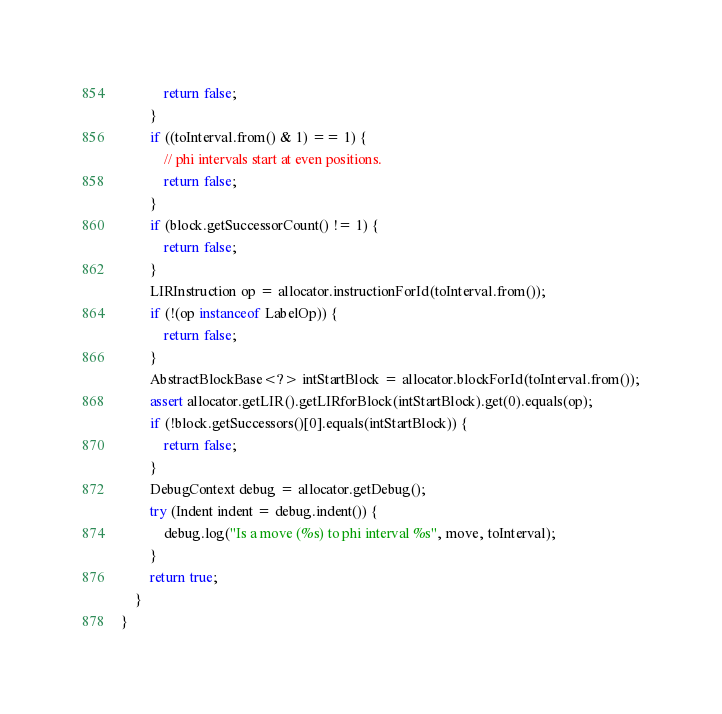<code> <loc_0><loc_0><loc_500><loc_500><_Java_>            return false;
        }
        if ((toInterval.from() & 1) == 1) {
            // phi intervals start at even positions.
            return false;
        }
        if (block.getSuccessorCount() != 1) {
            return false;
        }
        LIRInstruction op = allocator.instructionForId(toInterval.from());
        if (!(op instanceof LabelOp)) {
            return false;
        }
        AbstractBlockBase<?> intStartBlock = allocator.blockForId(toInterval.from());
        assert allocator.getLIR().getLIRforBlock(intStartBlock).get(0).equals(op);
        if (!block.getSuccessors()[0].equals(intStartBlock)) {
            return false;
        }
        DebugContext debug = allocator.getDebug();
        try (Indent indent = debug.indent()) {
            debug.log("Is a move (%s) to phi interval %s", move, toInterval);
        }
        return true;
    }
}
</code> 